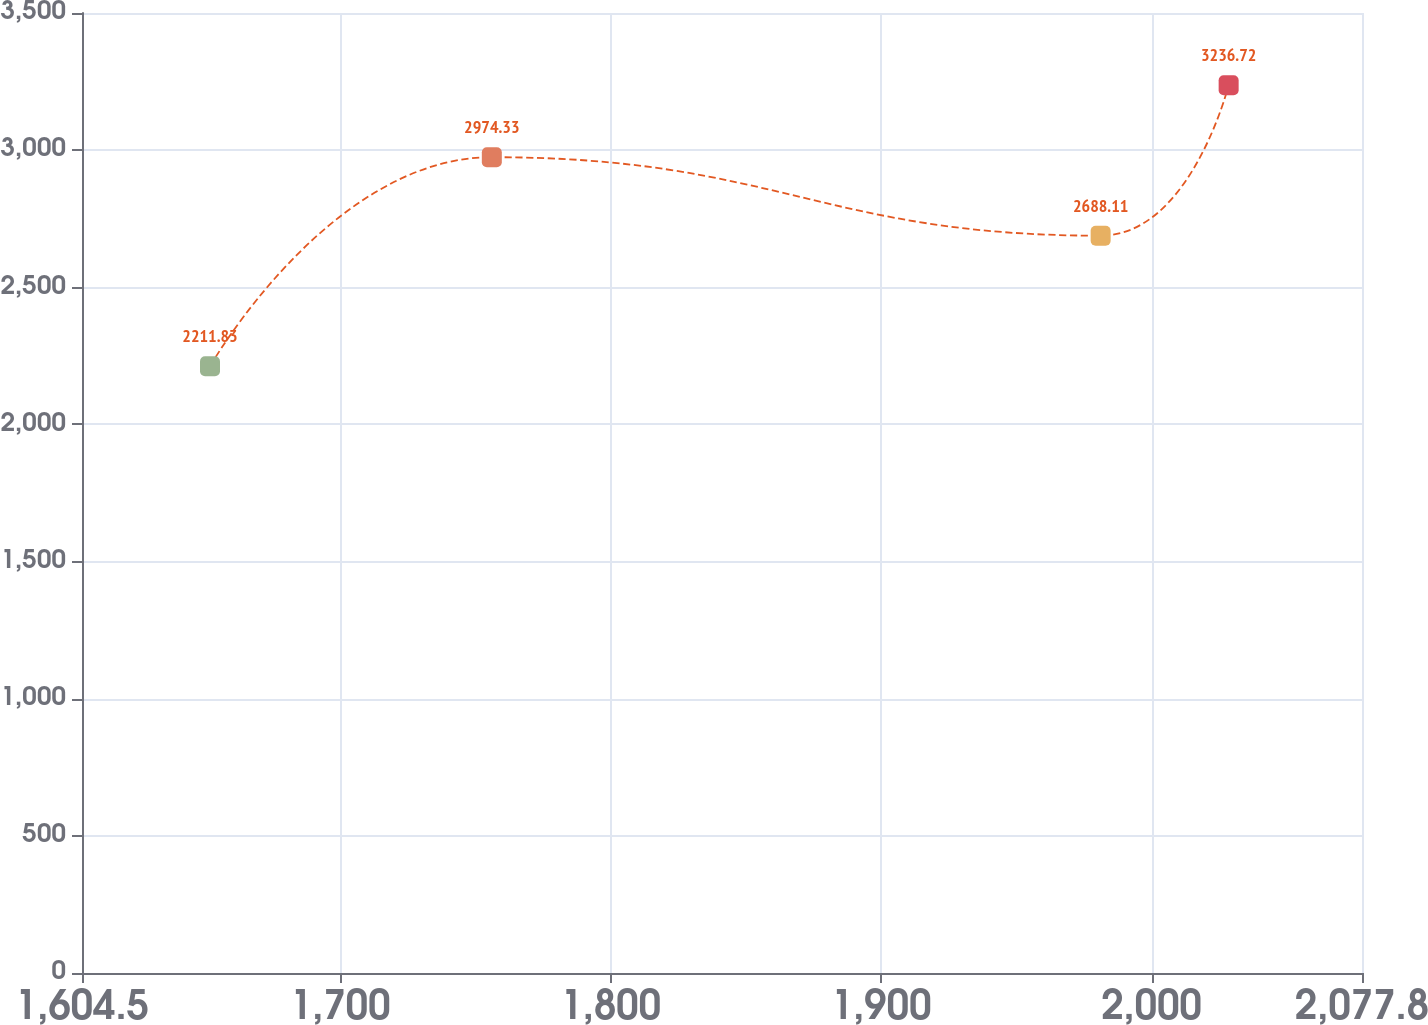Convert chart. <chart><loc_0><loc_0><loc_500><loc_500><line_chart><ecel><fcel>(in millions)<nl><fcel>1651.83<fcel>2211.83<nl><fcel>1756.04<fcel>2974.33<nl><fcel>1981.16<fcel>2688.11<nl><fcel>2028.49<fcel>3236.72<nl><fcel>2125.13<fcel>1885.76<nl></chart> 